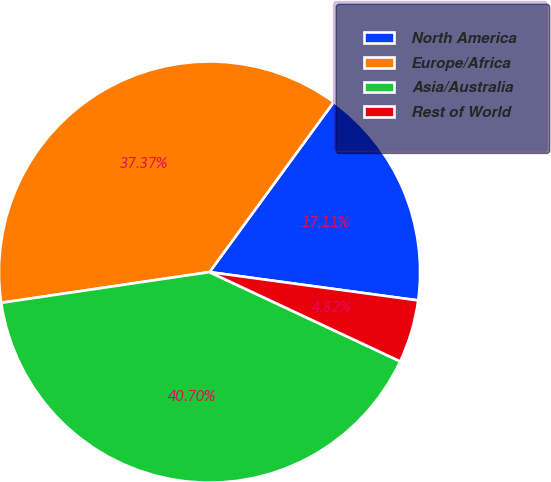Convert chart. <chart><loc_0><loc_0><loc_500><loc_500><pie_chart><fcel>North America<fcel>Europe/Africa<fcel>Asia/Australia<fcel>Rest of World<nl><fcel>17.11%<fcel>37.37%<fcel>40.7%<fcel>4.82%<nl></chart> 